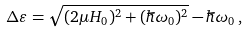<formula> <loc_0><loc_0><loc_500><loc_500>\Delta \varepsilon = \sqrt { ( 2 \mu H _ { 0 } ) ^ { 2 } + ( \hbar { \omega } _ { 0 } ) ^ { 2 } } - \hbar { \omega } _ { 0 } \, ,</formula> 